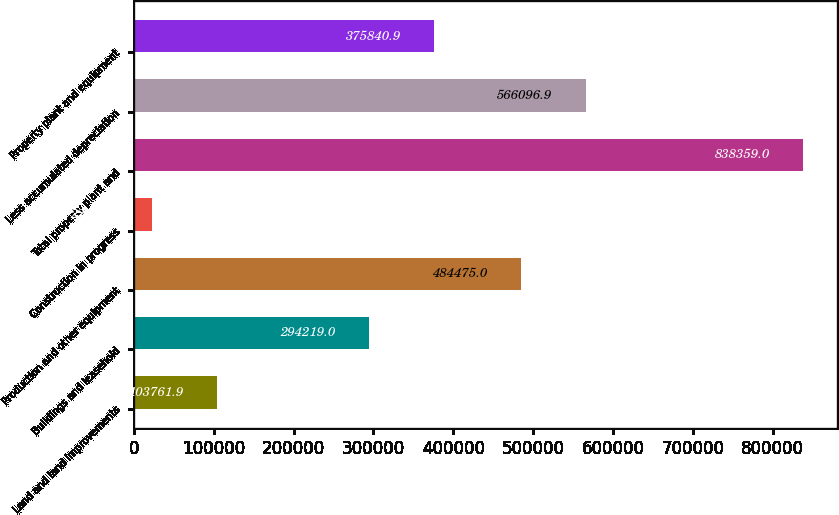Convert chart. <chart><loc_0><loc_0><loc_500><loc_500><bar_chart><fcel>Land and land improvements<fcel>Buildings and leasehold<fcel>Production and other equipment<fcel>Construction in progress<fcel>Total property plant and<fcel>Less accumulated depreciation<fcel>Property plant and equipment<nl><fcel>103762<fcel>294219<fcel>484475<fcel>22140<fcel>838359<fcel>566097<fcel>375841<nl></chart> 